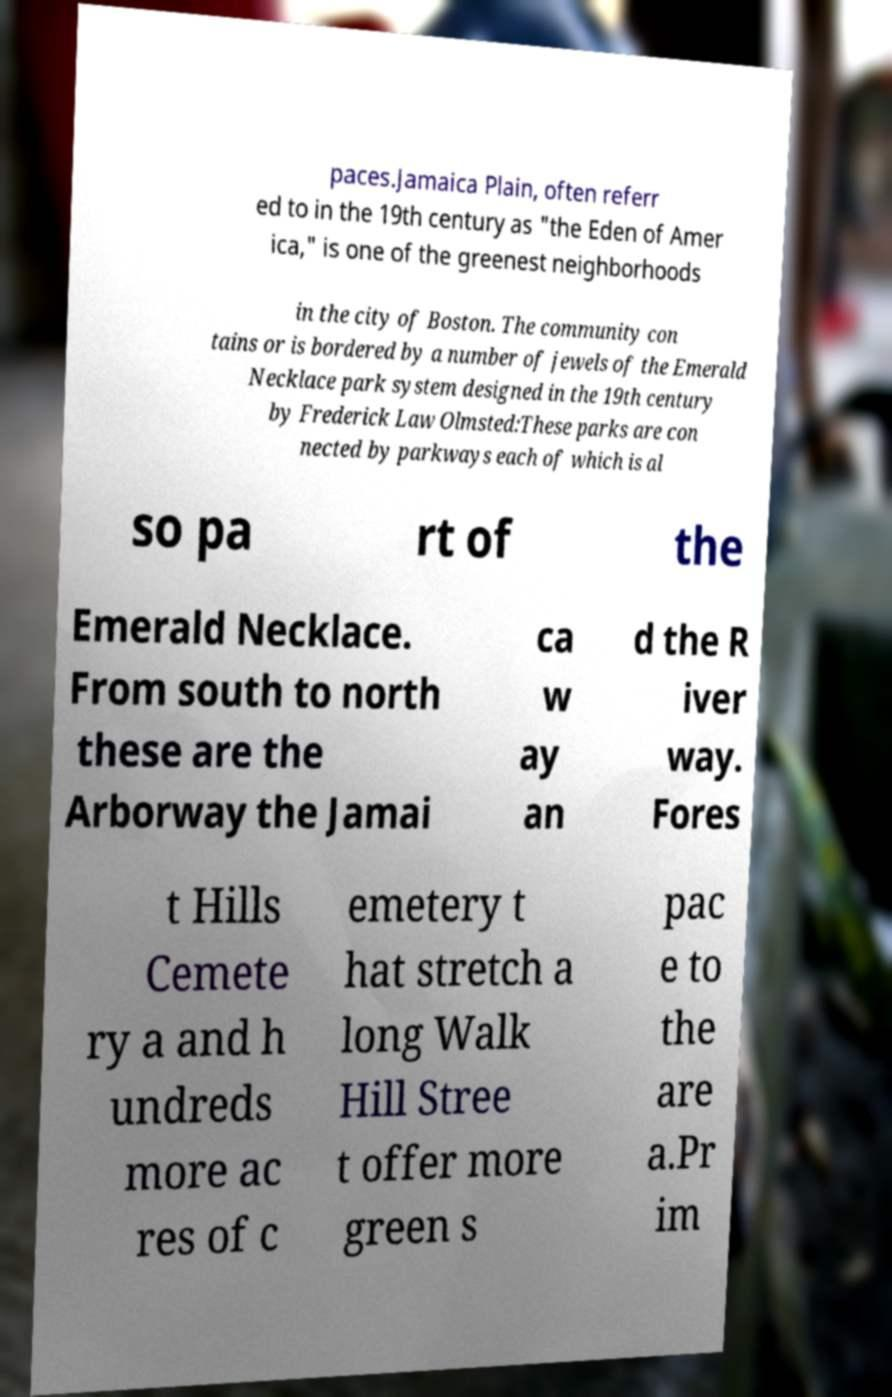Could you extract and type out the text from this image? paces.Jamaica Plain, often referr ed to in the 19th century as "the Eden of Amer ica," is one of the greenest neighborhoods in the city of Boston. The community con tains or is bordered by a number of jewels of the Emerald Necklace park system designed in the 19th century by Frederick Law Olmsted:These parks are con nected by parkways each of which is al so pa rt of the Emerald Necklace. From south to north these are the Arborway the Jamai ca w ay an d the R iver way. Fores t Hills Cemete ry a and h undreds more ac res of c emetery t hat stretch a long Walk Hill Stree t offer more green s pac e to the are a.Pr im 